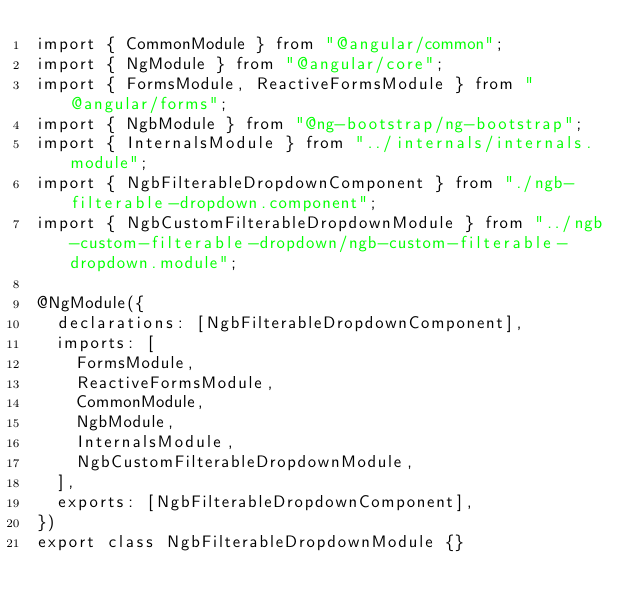Convert code to text. <code><loc_0><loc_0><loc_500><loc_500><_TypeScript_>import { CommonModule } from "@angular/common";
import { NgModule } from "@angular/core";
import { FormsModule, ReactiveFormsModule } from "@angular/forms";
import { NgbModule } from "@ng-bootstrap/ng-bootstrap";
import { InternalsModule } from "../internals/internals.module";
import { NgbFilterableDropdownComponent } from "./ngb-filterable-dropdown.component";
import { NgbCustomFilterableDropdownModule } from "../ngb-custom-filterable-dropdown/ngb-custom-filterable-dropdown.module";

@NgModule({
  declarations: [NgbFilterableDropdownComponent],
  imports: [
    FormsModule,
    ReactiveFormsModule,
    CommonModule,
    NgbModule,
    InternalsModule,
    NgbCustomFilterableDropdownModule,
  ],
  exports: [NgbFilterableDropdownComponent],
})
export class NgbFilterableDropdownModule {}
</code> 